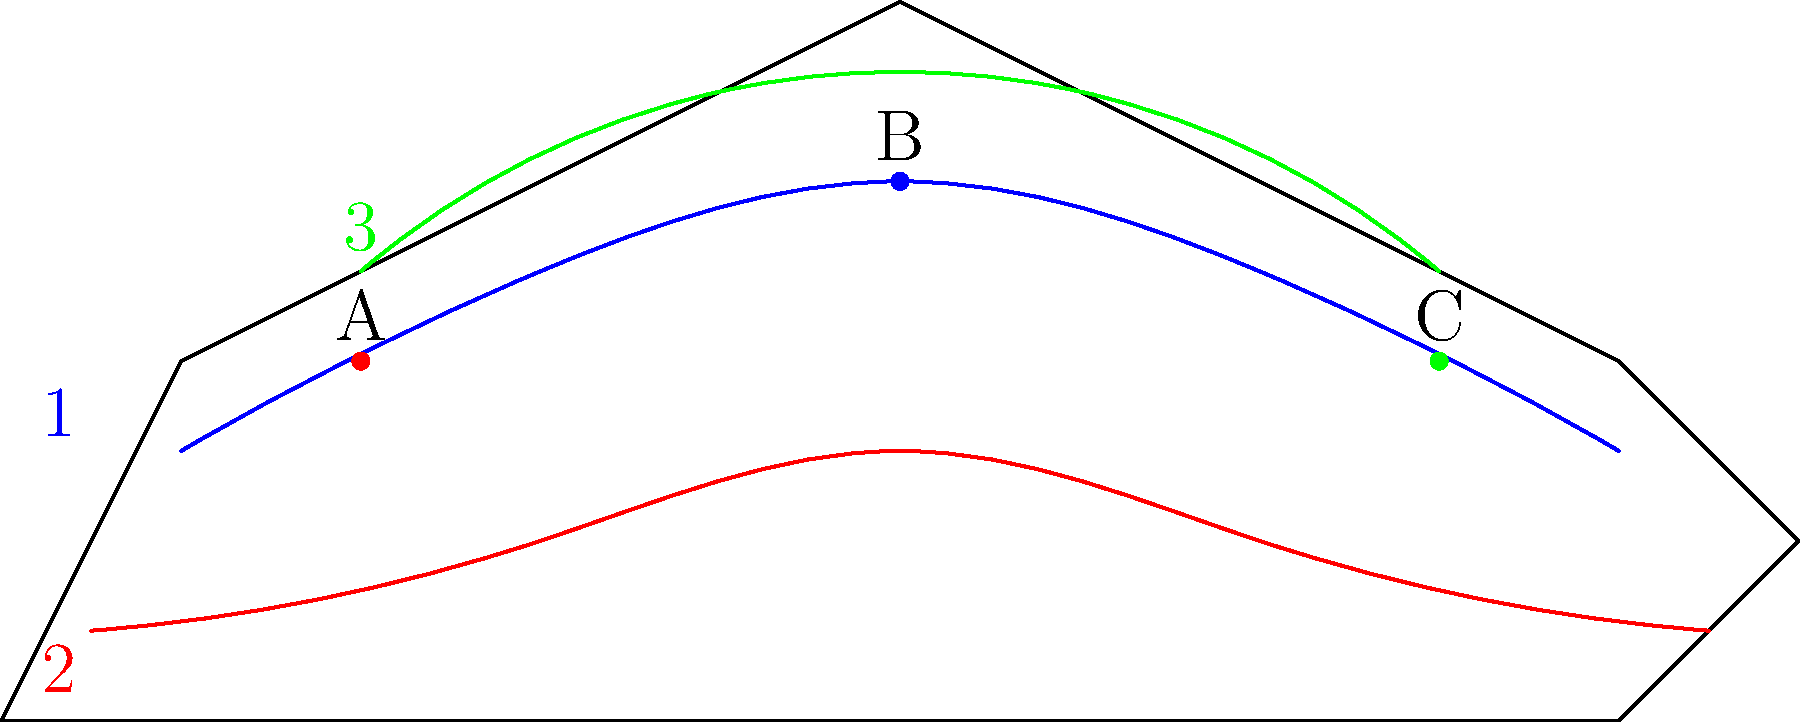Match the ancient trade routes (1-blue, 2-red, 3-green) with their corresponding geographical features (A-Mountains, B-Desert, C-Coastal city) on the world map. Which combination correctly pairs each route with its most significant geographical feature? To solve this puzzle, we need to analyze each trade route and its relationship to the geographical features:

1. The blue route (1) stretches across the entire map, passing through the central point B, which represents a desert. This aligns with the historical Silk Road that traversed the deserts of Central Asia.

2. The red route (2) follows a more southerly path, connecting coastal regions. It passes closest to point C, which represents a coastal city. This matches the maritime Spice Route that linked port cities.

3. The green route (3) takes a northerly path, passing closest to point A, which represents mountains. This corresponds to the Incense Route that often crossed mountainous regions in Arabia and the Levant.

Therefore, the correct pairings are:
1 (Blue) - B (Desert): Silk Road
2 (Red) - C (Coastal city): Spice Route
3 (Green) - A (Mountains): Incense Route
Answer: 1B, 2C, 3A 